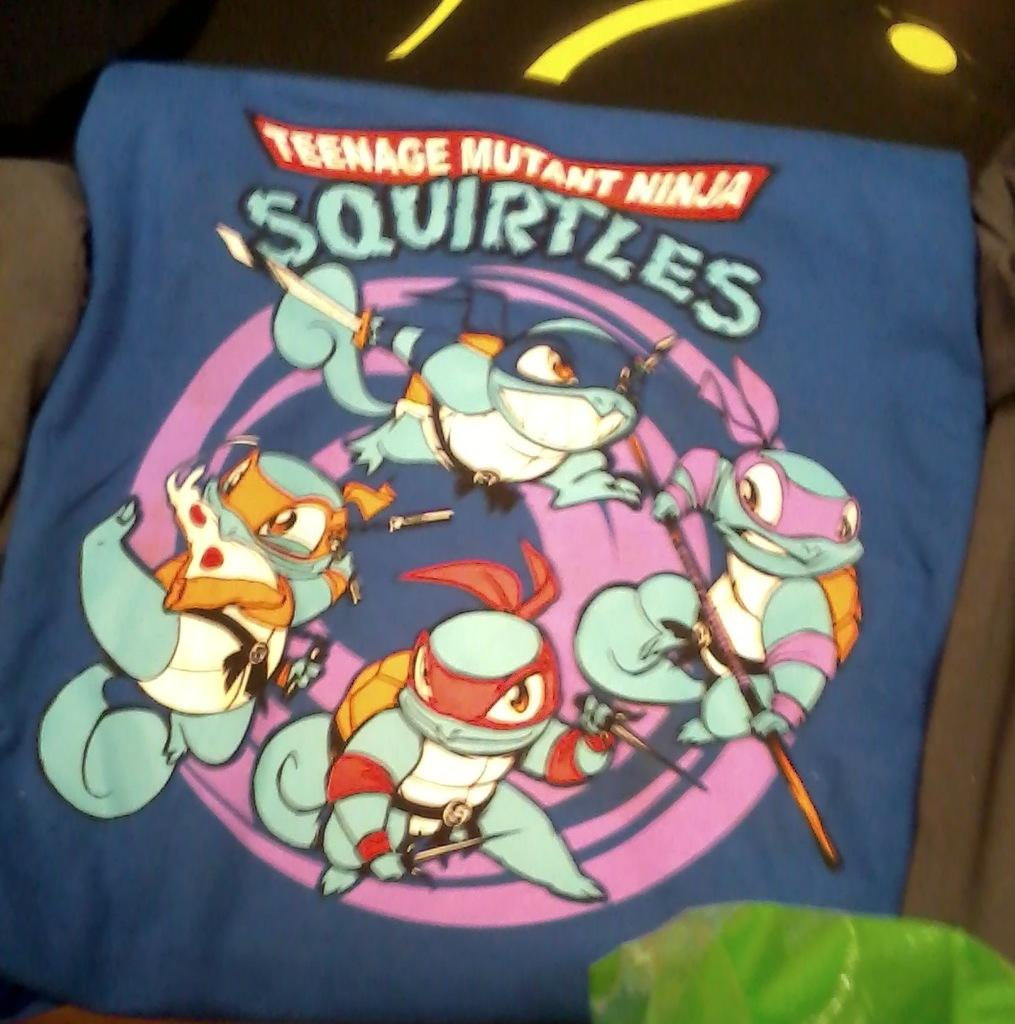What type of items can be seen in the image? There are clothes in the image. Can you see a crow perched on the bridge in the image? There is no crow or bridge present in the image; it only features clothes. 